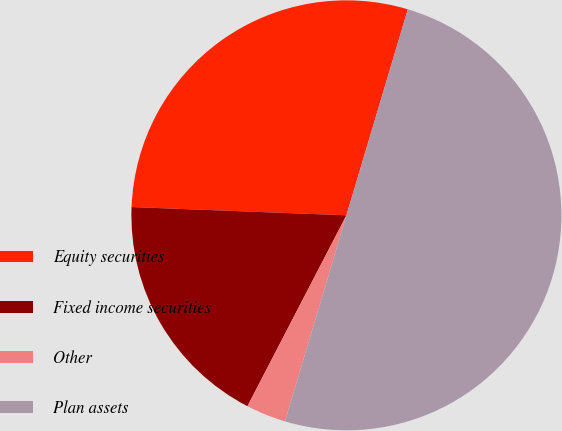<chart> <loc_0><loc_0><loc_500><loc_500><pie_chart><fcel>Equity securities<fcel>Fixed income securities<fcel>Other<fcel>Plan assets<nl><fcel>29.0%<fcel>18.0%<fcel>3.0%<fcel>50.0%<nl></chart> 